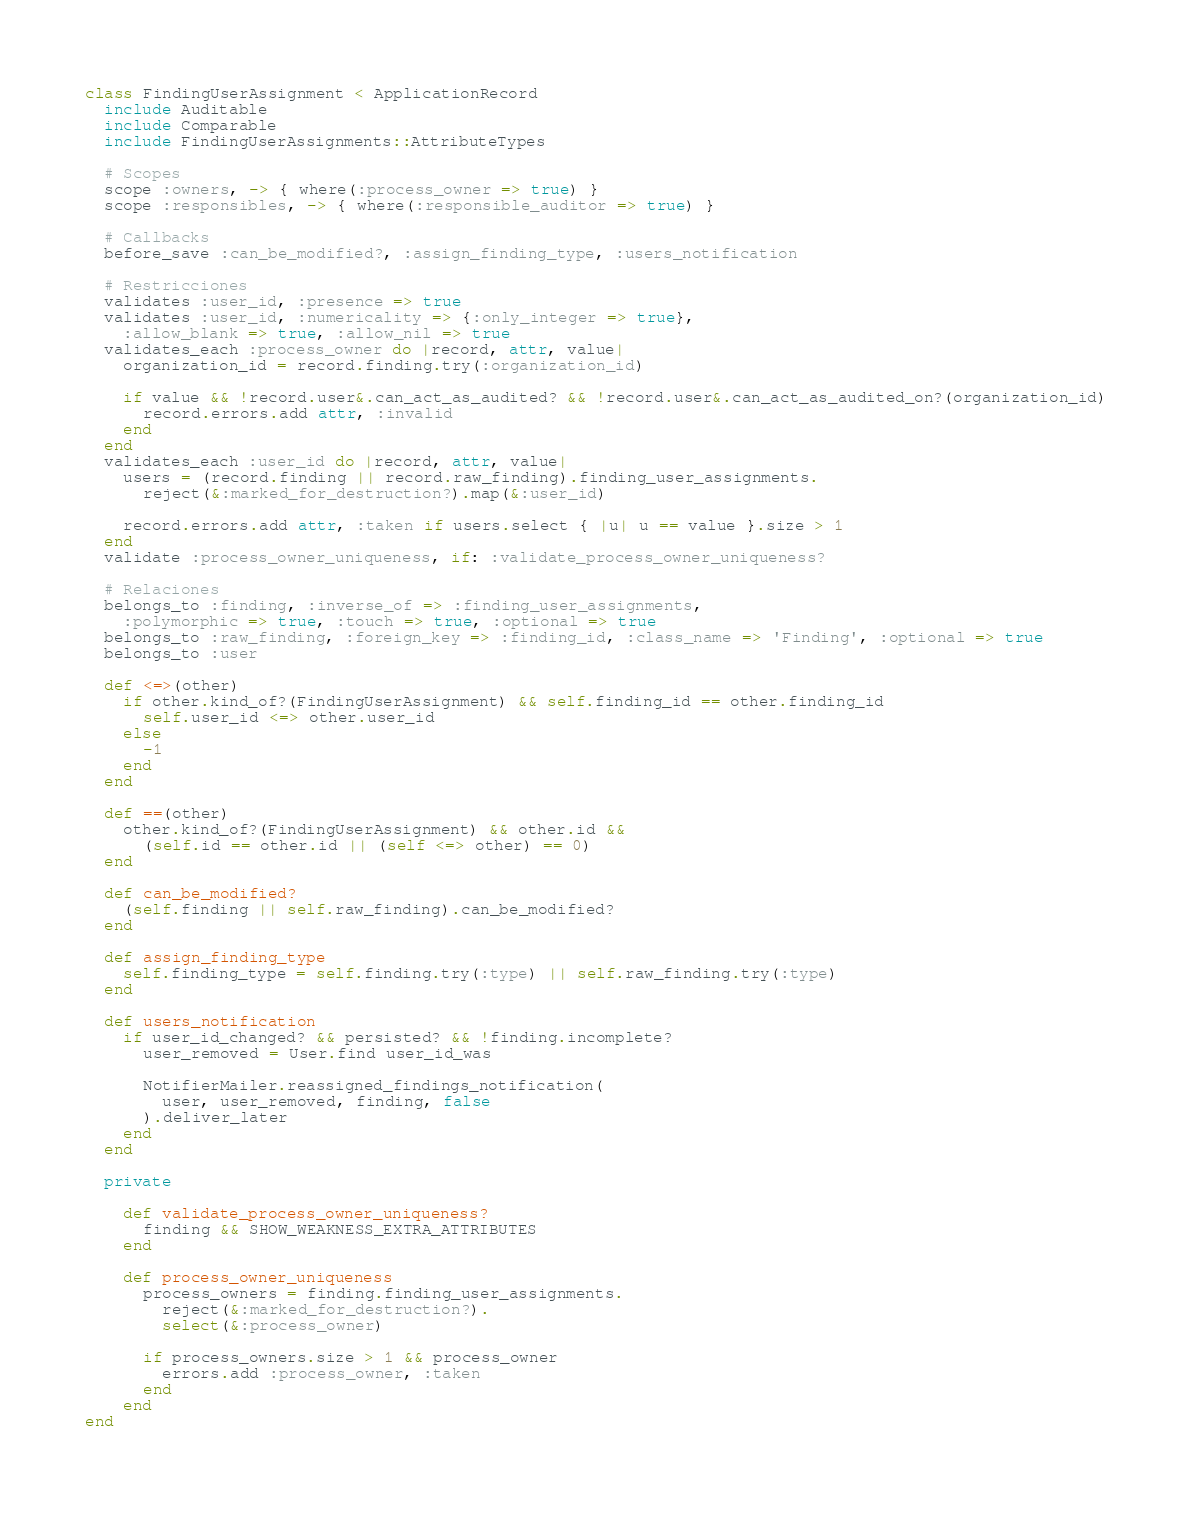<code> <loc_0><loc_0><loc_500><loc_500><_Ruby_>class FindingUserAssignment < ApplicationRecord
  include Auditable
  include Comparable
  include FindingUserAssignments::AttributeTypes

  # Scopes
  scope :owners, -> { where(:process_owner => true) }
  scope :responsibles, -> { where(:responsible_auditor => true) }

  # Callbacks
  before_save :can_be_modified?, :assign_finding_type, :users_notification

  # Restricciones
  validates :user_id, :presence => true
  validates :user_id, :numericality => {:only_integer => true},
    :allow_blank => true, :allow_nil => true
  validates_each :process_owner do |record, attr, value|
    organization_id = record.finding.try(:organization_id)

    if value && !record.user&.can_act_as_audited? && !record.user&.can_act_as_audited_on?(organization_id)
      record.errors.add attr, :invalid
    end
  end
  validates_each :user_id do |record, attr, value|
    users = (record.finding || record.raw_finding).finding_user_assignments.
      reject(&:marked_for_destruction?).map(&:user_id)

    record.errors.add attr, :taken if users.select { |u| u == value }.size > 1
  end
  validate :process_owner_uniqueness, if: :validate_process_owner_uniqueness?

  # Relaciones
  belongs_to :finding, :inverse_of => :finding_user_assignments,
    :polymorphic => true, :touch => true, :optional => true
  belongs_to :raw_finding, :foreign_key => :finding_id, :class_name => 'Finding', :optional => true
  belongs_to :user

  def <=>(other)
    if other.kind_of?(FindingUserAssignment) && self.finding_id == other.finding_id
      self.user_id <=> other.user_id
    else
      -1
    end
  end

  def ==(other)
    other.kind_of?(FindingUserAssignment) && other.id &&
      (self.id == other.id || (self <=> other) == 0)
  end

  def can_be_modified?
    (self.finding || self.raw_finding).can_be_modified?
  end

  def assign_finding_type
    self.finding_type = self.finding.try(:type) || self.raw_finding.try(:type)
  end

  def users_notification
    if user_id_changed? && persisted? && !finding.incomplete?
      user_removed = User.find user_id_was

      NotifierMailer.reassigned_findings_notification(
        user, user_removed, finding, false
      ).deliver_later
    end
  end

  private

    def validate_process_owner_uniqueness?
      finding && SHOW_WEAKNESS_EXTRA_ATTRIBUTES
    end

    def process_owner_uniqueness
      process_owners = finding.finding_user_assignments.
        reject(&:marked_for_destruction?).
        select(&:process_owner)

      if process_owners.size > 1 && process_owner
        errors.add :process_owner, :taken
      end
    end
end
</code> 